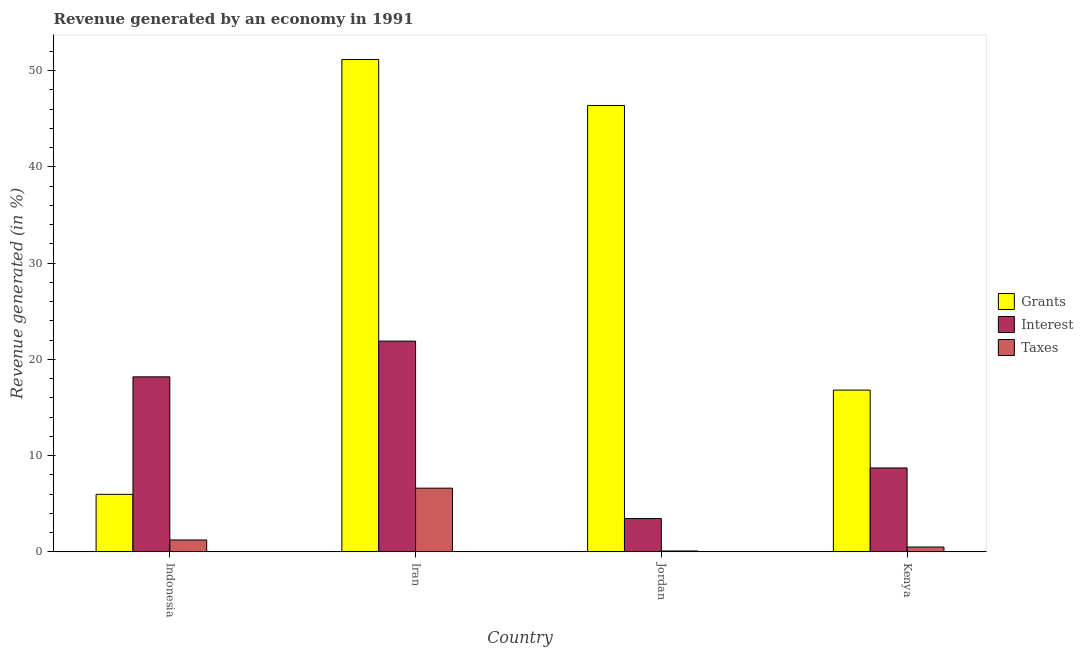How many different coloured bars are there?
Your answer should be very brief. 3. How many groups of bars are there?
Your response must be concise. 4. Are the number of bars on each tick of the X-axis equal?
Your response must be concise. Yes. What is the label of the 3rd group of bars from the left?
Your answer should be very brief. Jordan. What is the percentage of revenue generated by grants in Kenya?
Give a very brief answer. 16.81. Across all countries, what is the maximum percentage of revenue generated by taxes?
Provide a short and direct response. 6.62. Across all countries, what is the minimum percentage of revenue generated by grants?
Offer a terse response. 5.98. In which country was the percentage of revenue generated by interest maximum?
Offer a terse response. Iran. In which country was the percentage of revenue generated by taxes minimum?
Give a very brief answer. Jordan. What is the total percentage of revenue generated by interest in the graph?
Ensure brevity in your answer.  52.27. What is the difference between the percentage of revenue generated by grants in Jordan and that in Kenya?
Offer a terse response. 29.58. What is the difference between the percentage of revenue generated by interest in Kenya and the percentage of revenue generated by grants in Indonesia?
Offer a terse response. 2.74. What is the average percentage of revenue generated by taxes per country?
Your response must be concise. 2.11. What is the difference between the percentage of revenue generated by taxes and percentage of revenue generated by grants in Kenya?
Offer a terse response. -16.31. In how many countries, is the percentage of revenue generated by interest greater than 20 %?
Keep it short and to the point. 1. What is the ratio of the percentage of revenue generated by interest in Jordan to that in Kenya?
Provide a short and direct response. 0.4. What is the difference between the highest and the second highest percentage of revenue generated by interest?
Offer a terse response. 3.71. What is the difference between the highest and the lowest percentage of revenue generated by interest?
Offer a very short reply. 18.44. In how many countries, is the percentage of revenue generated by interest greater than the average percentage of revenue generated by interest taken over all countries?
Make the answer very short. 2. Is the sum of the percentage of revenue generated by interest in Jordan and Kenya greater than the maximum percentage of revenue generated by taxes across all countries?
Your answer should be compact. Yes. What does the 3rd bar from the left in Jordan represents?
Keep it short and to the point. Taxes. What does the 1st bar from the right in Kenya represents?
Provide a succinct answer. Taxes. Is it the case that in every country, the sum of the percentage of revenue generated by grants and percentage of revenue generated by interest is greater than the percentage of revenue generated by taxes?
Offer a terse response. Yes. Are all the bars in the graph horizontal?
Your answer should be very brief. No. What is the difference between two consecutive major ticks on the Y-axis?
Your answer should be very brief. 10. Does the graph contain any zero values?
Keep it short and to the point. No. Does the graph contain grids?
Your response must be concise. No. What is the title of the graph?
Offer a terse response. Revenue generated by an economy in 1991. What is the label or title of the Y-axis?
Give a very brief answer. Revenue generated (in %). What is the Revenue generated (in %) in Grants in Indonesia?
Your answer should be compact. 5.98. What is the Revenue generated (in %) of Interest in Indonesia?
Provide a short and direct response. 18.19. What is the Revenue generated (in %) of Taxes in Indonesia?
Ensure brevity in your answer.  1.24. What is the Revenue generated (in %) in Grants in Iran?
Your answer should be very brief. 51.17. What is the Revenue generated (in %) of Interest in Iran?
Make the answer very short. 21.9. What is the Revenue generated (in %) in Taxes in Iran?
Provide a succinct answer. 6.62. What is the Revenue generated (in %) of Grants in Jordan?
Provide a succinct answer. 46.39. What is the Revenue generated (in %) in Interest in Jordan?
Offer a very short reply. 3.46. What is the Revenue generated (in %) of Taxes in Jordan?
Offer a terse response. 0.09. What is the Revenue generated (in %) of Grants in Kenya?
Give a very brief answer. 16.81. What is the Revenue generated (in %) of Interest in Kenya?
Give a very brief answer. 8.72. What is the Revenue generated (in %) in Taxes in Kenya?
Your answer should be compact. 0.5. Across all countries, what is the maximum Revenue generated (in %) of Grants?
Your response must be concise. 51.17. Across all countries, what is the maximum Revenue generated (in %) in Interest?
Give a very brief answer. 21.9. Across all countries, what is the maximum Revenue generated (in %) in Taxes?
Give a very brief answer. 6.62. Across all countries, what is the minimum Revenue generated (in %) in Grants?
Provide a short and direct response. 5.98. Across all countries, what is the minimum Revenue generated (in %) in Interest?
Make the answer very short. 3.46. Across all countries, what is the minimum Revenue generated (in %) of Taxes?
Provide a short and direct response. 0.09. What is the total Revenue generated (in %) in Grants in the graph?
Give a very brief answer. 120.35. What is the total Revenue generated (in %) in Interest in the graph?
Offer a terse response. 52.27. What is the total Revenue generated (in %) in Taxes in the graph?
Offer a terse response. 8.45. What is the difference between the Revenue generated (in %) in Grants in Indonesia and that in Iran?
Ensure brevity in your answer.  -45.19. What is the difference between the Revenue generated (in %) in Interest in Indonesia and that in Iran?
Your response must be concise. -3.71. What is the difference between the Revenue generated (in %) of Taxes in Indonesia and that in Iran?
Your response must be concise. -5.38. What is the difference between the Revenue generated (in %) of Grants in Indonesia and that in Jordan?
Keep it short and to the point. -40.41. What is the difference between the Revenue generated (in %) of Interest in Indonesia and that in Jordan?
Provide a short and direct response. 14.72. What is the difference between the Revenue generated (in %) in Taxes in Indonesia and that in Jordan?
Keep it short and to the point. 1.15. What is the difference between the Revenue generated (in %) of Grants in Indonesia and that in Kenya?
Your response must be concise. -10.83. What is the difference between the Revenue generated (in %) in Interest in Indonesia and that in Kenya?
Offer a terse response. 9.47. What is the difference between the Revenue generated (in %) of Taxes in Indonesia and that in Kenya?
Offer a very short reply. 0.73. What is the difference between the Revenue generated (in %) in Grants in Iran and that in Jordan?
Offer a very short reply. 4.78. What is the difference between the Revenue generated (in %) of Interest in Iran and that in Jordan?
Make the answer very short. 18.44. What is the difference between the Revenue generated (in %) in Taxes in Iran and that in Jordan?
Your answer should be compact. 6.53. What is the difference between the Revenue generated (in %) in Grants in Iran and that in Kenya?
Your answer should be compact. 34.35. What is the difference between the Revenue generated (in %) in Interest in Iran and that in Kenya?
Make the answer very short. 13.18. What is the difference between the Revenue generated (in %) of Taxes in Iran and that in Kenya?
Provide a succinct answer. 6.12. What is the difference between the Revenue generated (in %) in Grants in Jordan and that in Kenya?
Provide a short and direct response. 29.58. What is the difference between the Revenue generated (in %) of Interest in Jordan and that in Kenya?
Your response must be concise. -5.26. What is the difference between the Revenue generated (in %) of Taxes in Jordan and that in Kenya?
Keep it short and to the point. -0.41. What is the difference between the Revenue generated (in %) in Grants in Indonesia and the Revenue generated (in %) in Interest in Iran?
Your response must be concise. -15.92. What is the difference between the Revenue generated (in %) of Grants in Indonesia and the Revenue generated (in %) of Taxes in Iran?
Offer a terse response. -0.64. What is the difference between the Revenue generated (in %) in Interest in Indonesia and the Revenue generated (in %) in Taxes in Iran?
Give a very brief answer. 11.57. What is the difference between the Revenue generated (in %) in Grants in Indonesia and the Revenue generated (in %) in Interest in Jordan?
Your response must be concise. 2.52. What is the difference between the Revenue generated (in %) in Grants in Indonesia and the Revenue generated (in %) in Taxes in Jordan?
Offer a very short reply. 5.89. What is the difference between the Revenue generated (in %) in Interest in Indonesia and the Revenue generated (in %) in Taxes in Jordan?
Offer a terse response. 18.1. What is the difference between the Revenue generated (in %) in Grants in Indonesia and the Revenue generated (in %) in Interest in Kenya?
Provide a short and direct response. -2.74. What is the difference between the Revenue generated (in %) of Grants in Indonesia and the Revenue generated (in %) of Taxes in Kenya?
Provide a short and direct response. 5.48. What is the difference between the Revenue generated (in %) in Interest in Indonesia and the Revenue generated (in %) in Taxes in Kenya?
Your answer should be very brief. 17.68. What is the difference between the Revenue generated (in %) in Grants in Iran and the Revenue generated (in %) in Interest in Jordan?
Ensure brevity in your answer.  47.7. What is the difference between the Revenue generated (in %) of Grants in Iran and the Revenue generated (in %) of Taxes in Jordan?
Offer a very short reply. 51.08. What is the difference between the Revenue generated (in %) in Interest in Iran and the Revenue generated (in %) in Taxes in Jordan?
Provide a short and direct response. 21.81. What is the difference between the Revenue generated (in %) in Grants in Iran and the Revenue generated (in %) in Interest in Kenya?
Make the answer very short. 42.45. What is the difference between the Revenue generated (in %) of Grants in Iran and the Revenue generated (in %) of Taxes in Kenya?
Give a very brief answer. 50.66. What is the difference between the Revenue generated (in %) of Interest in Iran and the Revenue generated (in %) of Taxes in Kenya?
Your answer should be very brief. 21.4. What is the difference between the Revenue generated (in %) in Grants in Jordan and the Revenue generated (in %) in Interest in Kenya?
Provide a short and direct response. 37.67. What is the difference between the Revenue generated (in %) in Grants in Jordan and the Revenue generated (in %) in Taxes in Kenya?
Your answer should be compact. 45.89. What is the difference between the Revenue generated (in %) of Interest in Jordan and the Revenue generated (in %) of Taxes in Kenya?
Ensure brevity in your answer.  2.96. What is the average Revenue generated (in %) in Grants per country?
Your answer should be very brief. 30.09. What is the average Revenue generated (in %) of Interest per country?
Offer a terse response. 13.07. What is the average Revenue generated (in %) of Taxes per country?
Offer a terse response. 2.11. What is the difference between the Revenue generated (in %) in Grants and Revenue generated (in %) in Interest in Indonesia?
Offer a terse response. -12.21. What is the difference between the Revenue generated (in %) in Grants and Revenue generated (in %) in Taxes in Indonesia?
Your response must be concise. 4.74. What is the difference between the Revenue generated (in %) in Interest and Revenue generated (in %) in Taxes in Indonesia?
Provide a succinct answer. 16.95. What is the difference between the Revenue generated (in %) of Grants and Revenue generated (in %) of Interest in Iran?
Provide a short and direct response. 29.27. What is the difference between the Revenue generated (in %) in Grants and Revenue generated (in %) in Taxes in Iran?
Offer a very short reply. 44.55. What is the difference between the Revenue generated (in %) in Interest and Revenue generated (in %) in Taxes in Iran?
Keep it short and to the point. 15.28. What is the difference between the Revenue generated (in %) of Grants and Revenue generated (in %) of Interest in Jordan?
Your response must be concise. 42.93. What is the difference between the Revenue generated (in %) of Grants and Revenue generated (in %) of Taxes in Jordan?
Ensure brevity in your answer.  46.3. What is the difference between the Revenue generated (in %) in Interest and Revenue generated (in %) in Taxes in Jordan?
Offer a terse response. 3.37. What is the difference between the Revenue generated (in %) in Grants and Revenue generated (in %) in Interest in Kenya?
Your answer should be compact. 8.09. What is the difference between the Revenue generated (in %) in Grants and Revenue generated (in %) in Taxes in Kenya?
Offer a terse response. 16.31. What is the difference between the Revenue generated (in %) in Interest and Revenue generated (in %) in Taxes in Kenya?
Provide a succinct answer. 8.22. What is the ratio of the Revenue generated (in %) in Grants in Indonesia to that in Iran?
Your answer should be compact. 0.12. What is the ratio of the Revenue generated (in %) in Interest in Indonesia to that in Iran?
Offer a very short reply. 0.83. What is the ratio of the Revenue generated (in %) of Taxes in Indonesia to that in Iran?
Make the answer very short. 0.19. What is the ratio of the Revenue generated (in %) in Grants in Indonesia to that in Jordan?
Your answer should be compact. 0.13. What is the ratio of the Revenue generated (in %) of Interest in Indonesia to that in Jordan?
Your answer should be compact. 5.25. What is the ratio of the Revenue generated (in %) of Taxes in Indonesia to that in Jordan?
Ensure brevity in your answer.  13.52. What is the ratio of the Revenue generated (in %) in Grants in Indonesia to that in Kenya?
Keep it short and to the point. 0.36. What is the ratio of the Revenue generated (in %) in Interest in Indonesia to that in Kenya?
Provide a short and direct response. 2.09. What is the ratio of the Revenue generated (in %) in Taxes in Indonesia to that in Kenya?
Provide a succinct answer. 2.46. What is the ratio of the Revenue generated (in %) in Grants in Iran to that in Jordan?
Give a very brief answer. 1.1. What is the ratio of the Revenue generated (in %) in Interest in Iran to that in Jordan?
Provide a short and direct response. 6.32. What is the ratio of the Revenue generated (in %) in Taxes in Iran to that in Jordan?
Your answer should be compact. 72.32. What is the ratio of the Revenue generated (in %) of Grants in Iran to that in Kenya?
Give a very brief answer. 3.04. What is the ratio of the Revenue generated (in %) in Interest in Iran to that in Kenya?
Your answer should be very brief. 2.51. What is the ratio of the Revenue generated (in %) of Taxes in Iran to that in Kenya?
Make the answer very short. 13.14. What is the ratio of the Revenue generated (in %) in Grants in Jordan to that in Kenya?
Ensure brevity in your answer.  2.76. What is the ratio of the Revenue generated (in %) of Interest in Jordan to that in Kenya?
Your response must be concise. 0.4. What is the ratio of the Revenue generated (in %) of Taxes in Jordan to that in Kenya?
Offer a very short reply. 0.18. What is the difference between the highest and the second highest Revenue generated (in %) of Grants?
Offer a very short reply. 4.78. What is the difference between the highest and the second highest Revenue generated (in %) of Interest?
Offer a terse response. 3.71. What is the difference between the highest and the second highest Revenue generated (in %) in Taxes?
Your response must be concise. 5.38. What is the difference between the highest and the lowest Revenue generated (in %) of Grants?
Offer a terse response. 45.19. What is the difference between the highest and the lowest Revenue generated (in %) in Interest?
Provide a succinct answer. 18.44. What is the difference between the highest and the lowest Revenue generated (in %) of Taxes?
Give a very brief answer. 6.53. 